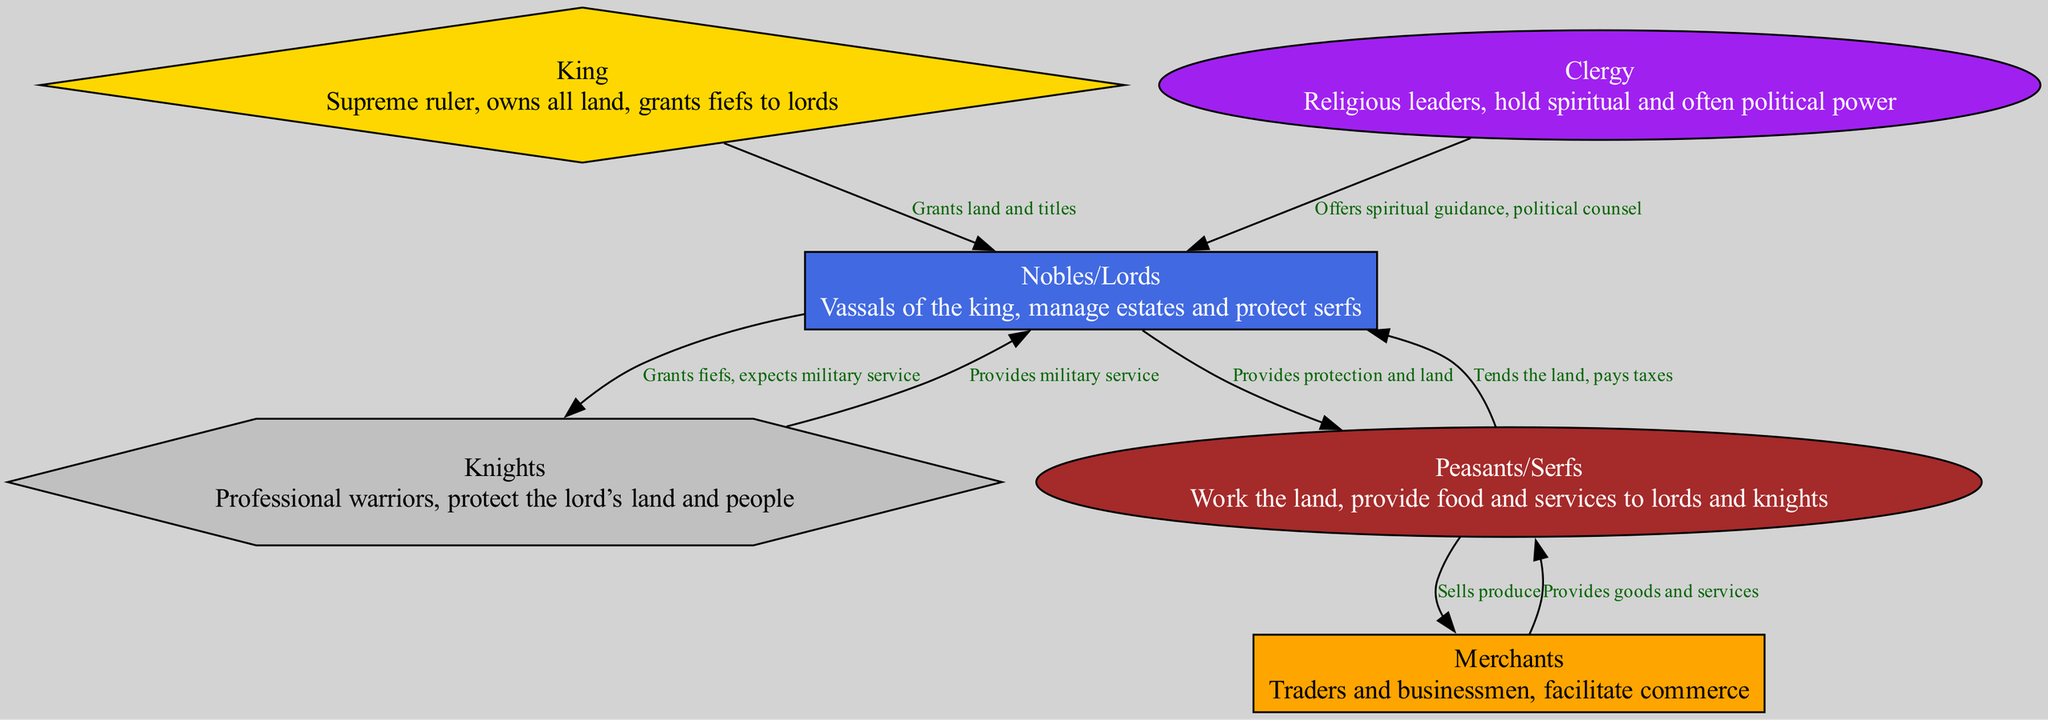What is the top node in the hierarchy? The top node is labeled "King," which represents the supreme ruler in the medieval castle society. This can be seen at the top of the diagram as it has no superior node above it.
Answer: King How many nodes are there in the diagram? By counting the total number of distinct roles represented in the diagram, we find that there are six nodes: King, Nobles/Lords, Knights, Clergy, Merchants, and Peasants/Serfs.
Answer: 6 What role provides military service? The "Knights" role is specifically connected to the "Nobles/Lords" as they provide military service in exchange for land granted to them. This is illustrated by the directed edge indicating their relationship.
Answer: Knights Which role sells produce? The "Peasants/Serfs" sell produce, as indicated by the relationship shown in the diagram where they interact with the Merchants to facilitate trade.
Answer: Peasants/Serfs What relationship exists between Clergy and Nobles/Lords? The Clergy offers spiritual guidance and political counsel to Nobles/Lords, which is indicated by a directed edge labeled with that specific relationship in the diagram.
Answer: Offers spiritual guidance, political counsel What is the relationship between Nobles/Lords and Peasants/Serfs? Nobles/Lords provide protection and land to Peasants/Serfs, while Peasants/Serfs tend to the land and pay taxes. This two-way relationship is represented by directed edges in both directions between these nodes.
Answer: Provides protection and land; tends the land, pays taxes Who grants titles and land? The "King" grants titles and land to the Nobles/Lords as depicted by the directed edge pointing from the King to Nobles/Lords labeled with that relationship.
Answer: King What role has a rectangular shape? The "Nobles/Lords" node is represented by a rectangle in the diagram. This specific shape is used to distinguish the Nobles from other roles visually.
Answer: Nobles/Lords 